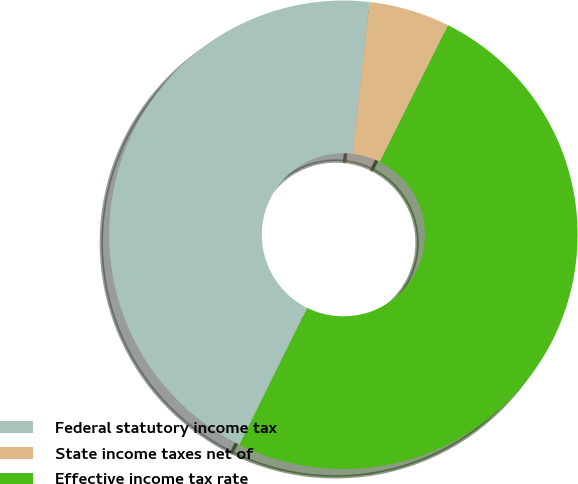Convert chart. <chart><loc_0><loc_0><loc_500><loc_500><pie_chart><fcel>Federal statutory income tax<fcel>State income taxes net of<fcel>Effective income tax rate<nl><fcel>44.47%<fcel>5.59%<fcel>49.94%<nl></chart> 